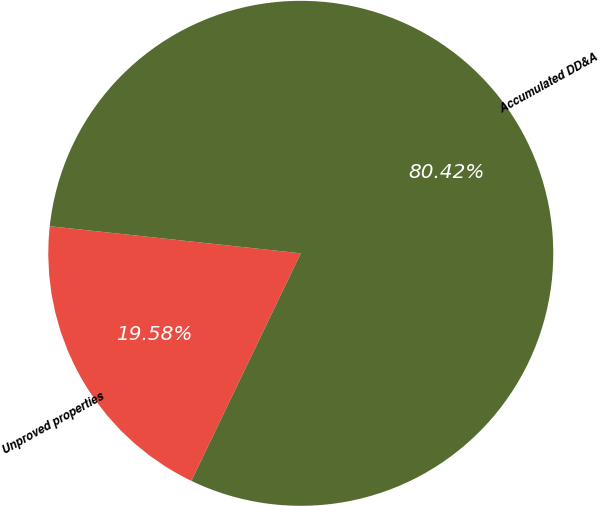Convert chart to OTSL. <chart><loc_0><loc_0><loc_500><loc_500><pie_chart><fcel>Unproved properties<fcel>Accumulated DD&A<nl><fcel>19.58%<fcel>80.42%<nl></chart> 